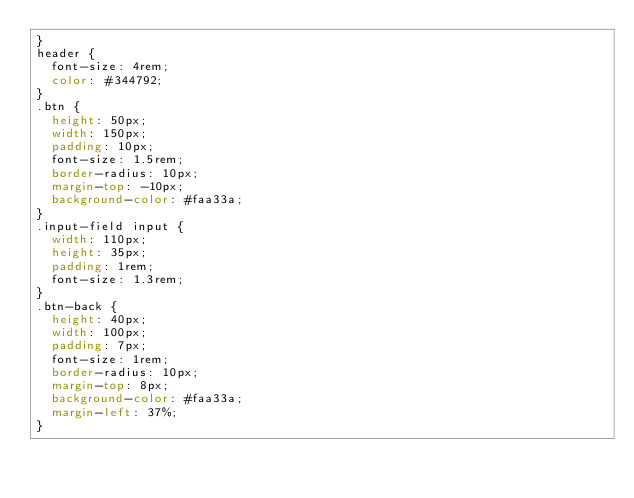Convert code to text. <code><loc_0><loc_0><loc_500><loc_500><_CSS_>}
header {
  font-size: 4rem;
  color: #344792;
}
.btn {
  height: 50px;
  width: 150px;
  padding: 10px;
  font-size: 1.5rem;
  border-radius: 10px;
  margin-top: -10px;
  background-color: #faa33a;
}
.input-field input {
  width: 110px;
  height: 35px;
  padding: 1rem;
  font-size: 1.3rem;
}
.btn-back {
  height: 40px;
  width: 100px;
  padding: 7px;
  font-size: 1rem;
  border-radius: 10px;
  margin-top: 8px;
  background-color: #faa33a;
  margin-left: 37%;
}
</code> 